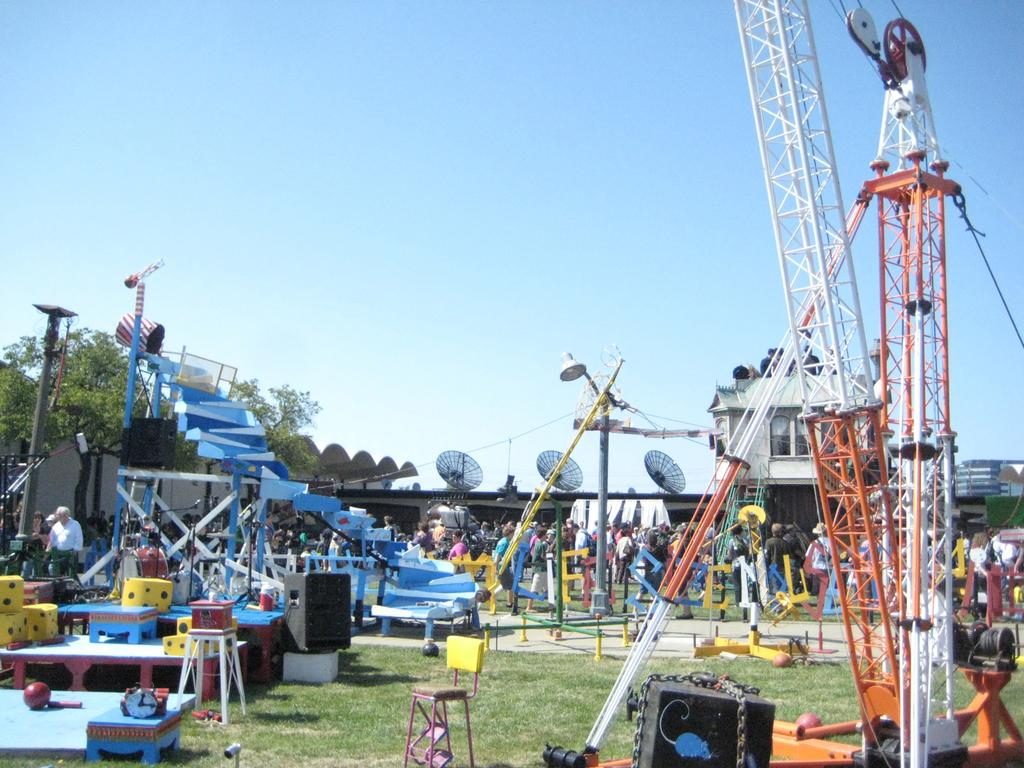What type of equipment can be seen in the image? There are satellite dishes, a crane, rods, speakers, and a light pole visible in the image. Are there any people present in the image? Yes, there are people in the image. What objects can be found on a table in the image? There is a table in the image, and dices are present on it. What natural elements can be seen in the image? There is a tree, grass, and sky visible in the image. What type of structure is present in the image? There is a building in the image. Can you tell me how many seeds are in the can in the image? There is no can or seeds present in the image. What type of scissors are being used to cut the ball in the image? There is no scissors or ball being cut in the image. 